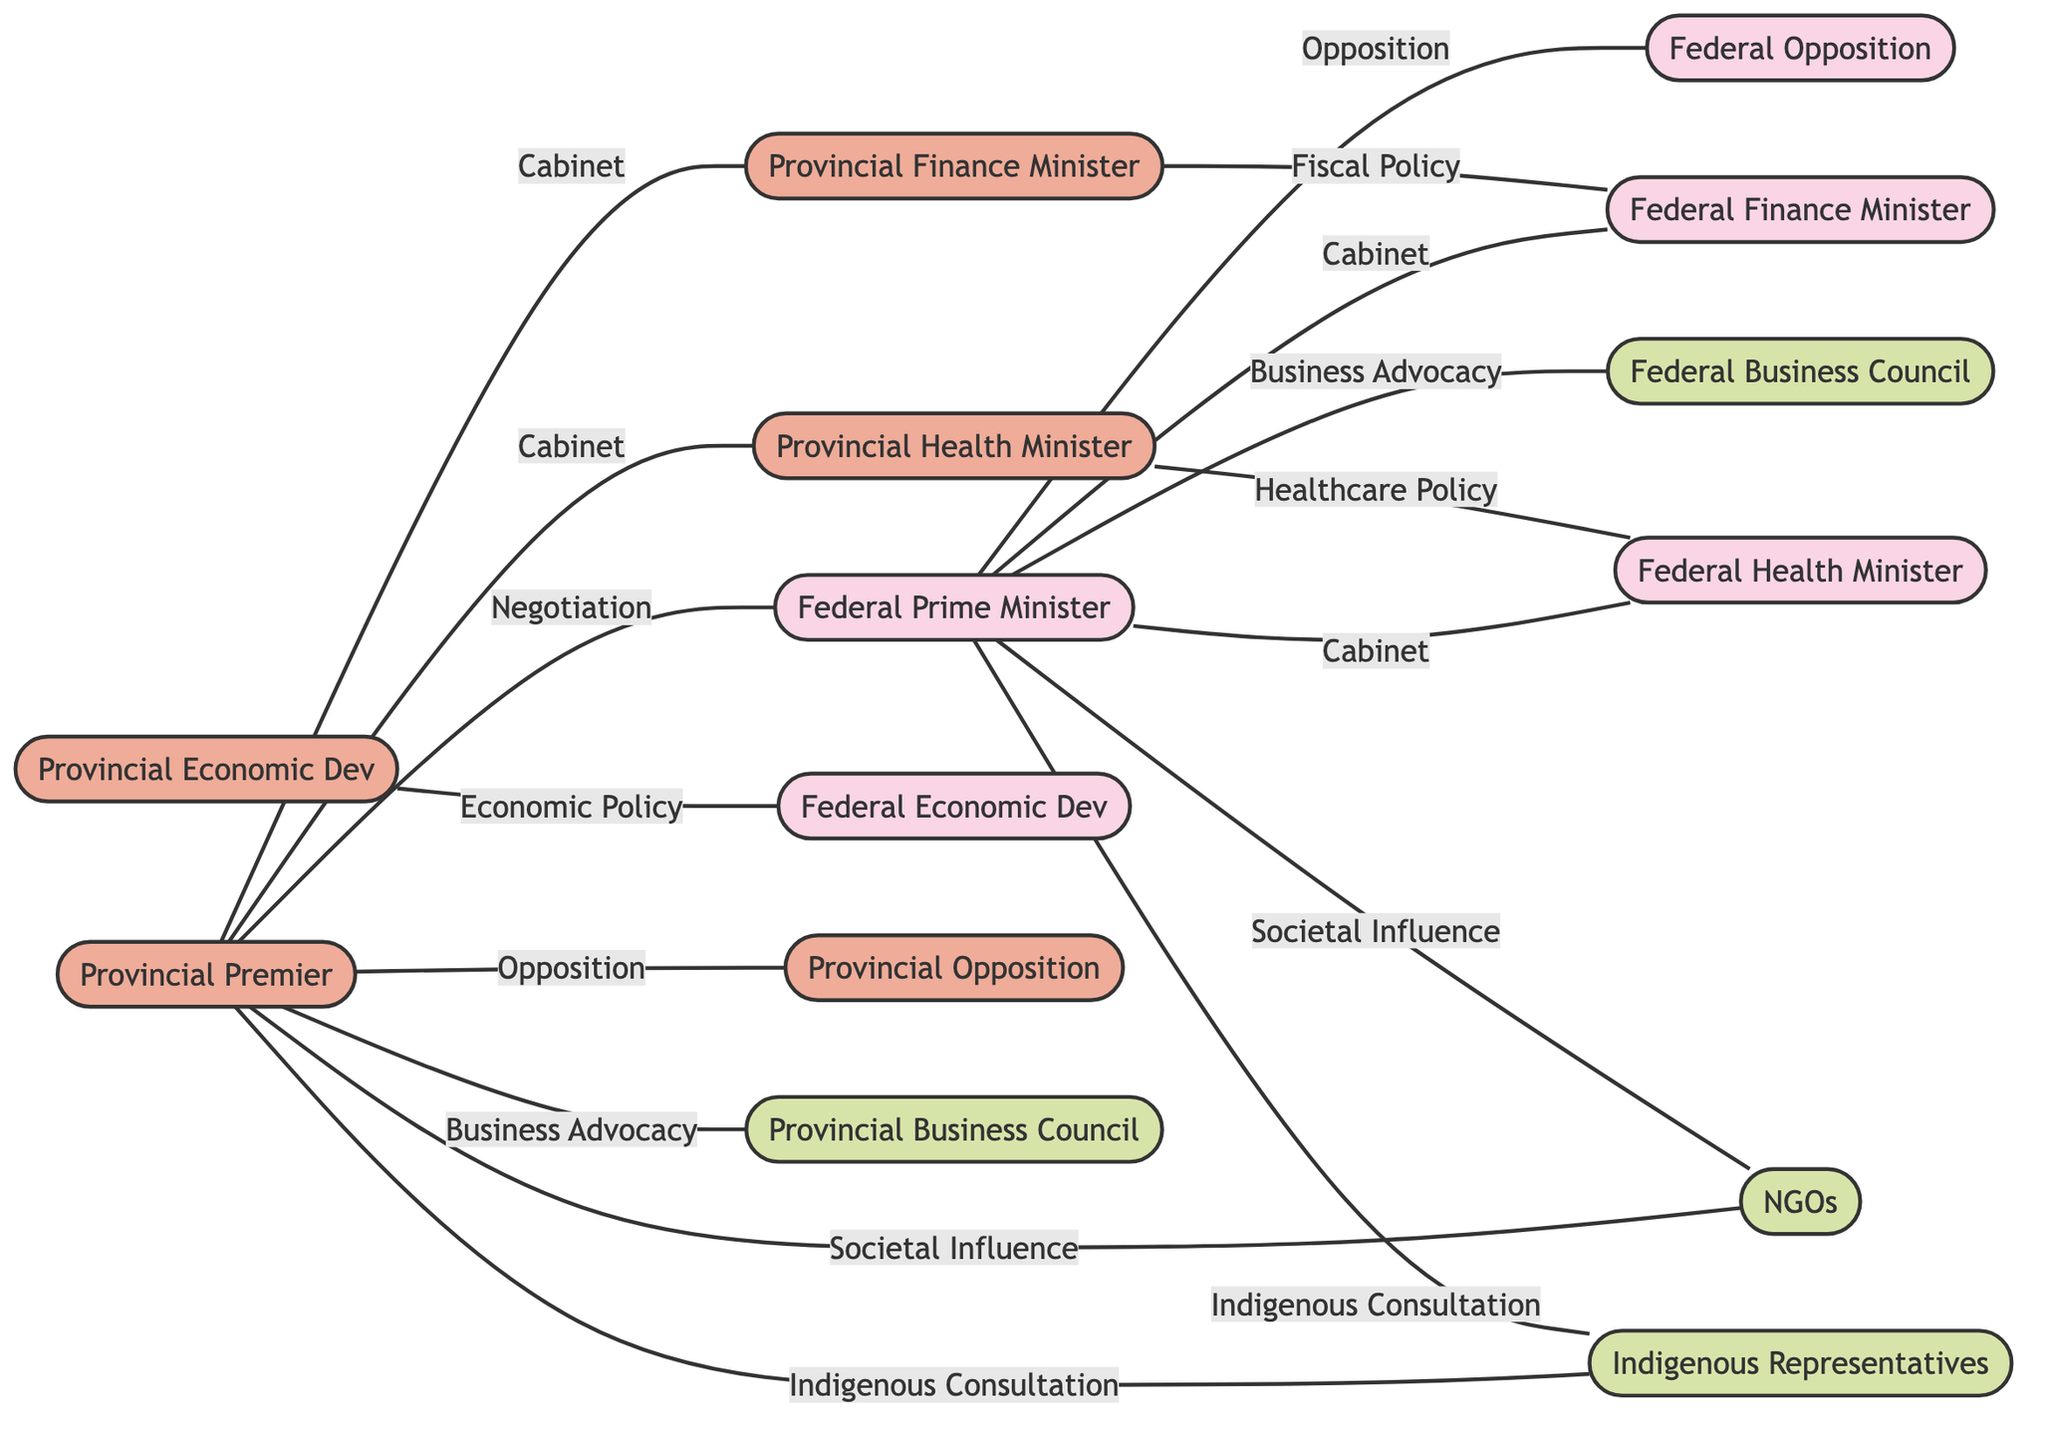What is the relationship between the Provincial Premier and the Federal Prime Minister? The diagram indicates a direct connection between the Provincial Premier and the Federal Prime Minister labeled as "Negotiation Partner". This shows that they are directly involved in negotiations with each other.
Answer: Negotiation Partner How many total nodes are in the diagram? By counting the unique individuals and organizations represented, I found there are 14 nodes in total listed in the nodes section of the data.
Answer: 14 Who is connected to the Provincial Finance Minister? The Provincial Finance Minister is connected to the Provincial Premier as a member of the "Provincial Cabinet", and also has a connection to the Federal Finance Minister through "Fiscal Policy Coordination".
Answer: Provincial Premier, Federal Finance Minister What type of influence do both Provincial and Federal governments have over Non-Governmental Organizations? Both the Provincial Premier and the Federal Prime Minister are connected to Non-Governmental Organizations through the relationship labeled "Societal Influence", indicating they both have a societal influence over these organizations.
Answer: Societal Influence Which two leadership roles are involved in Indigenous Consultation? The diagram shows that both the Provincial Premier and the Federal Prime Minister are linked to Indigenous Leadership Representatives through "Indigenous Consultation", meaning both play a role in consulting with Indigenous groups.
Answer: Provincial Premier, Federal Prime Minister How many edges are there in the graph? The edges represent the various relationships and there are 14 edges connecting the nodes, each showing the nature of various interactions.
Answer: 14 What is the relationship connecting the Provincial Health Minister to the Federal Health Minister? The graph displays the connection between the Provincial Health Minister and the Federal Health Minister as "Healthcare Policy Coordination", indicating their collaborative efforts in health policy.
Answer: Healthcare Policy Coordination What do the edges represent in this diagram? The edges illustrate the various forms of relationships, influence, or coordination actions between the different stakeholders involved in federal-provincial negotiations as highlighted by specific labels.
Answer: Relationships and influence Between which ministers is there a connection labeled "Economic Policy Coordination"? This connection is depicted between the Provincial Economic Development Office and the Federal Economic Development Office, indicating a collaborative approach to economic policies.
Answer: Provincial Economic Development Office, Federal Economic Development Office 